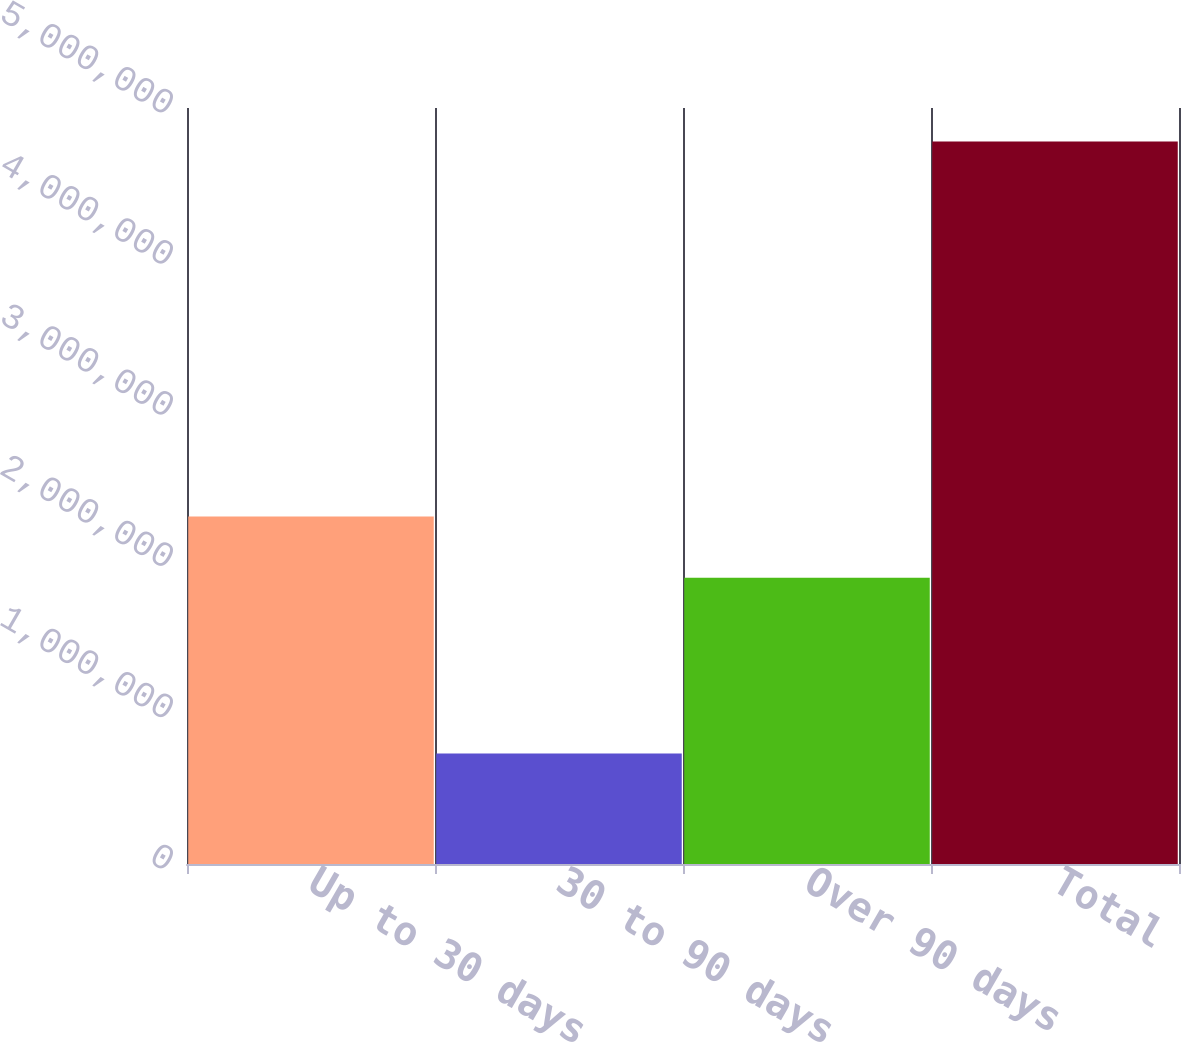Convert chart. <chart><loc_0><loc_0><loc_500><loc_500><bar_chart><fcel>Up to 30 days<fcel>30 to 90 days<fcel>Over 90 days<fcel>Total<nl><fcel>2.29756e+06<fcel>730216<fcel>1.8927e+06<fcel>4.77877e+06<nl></chart> 